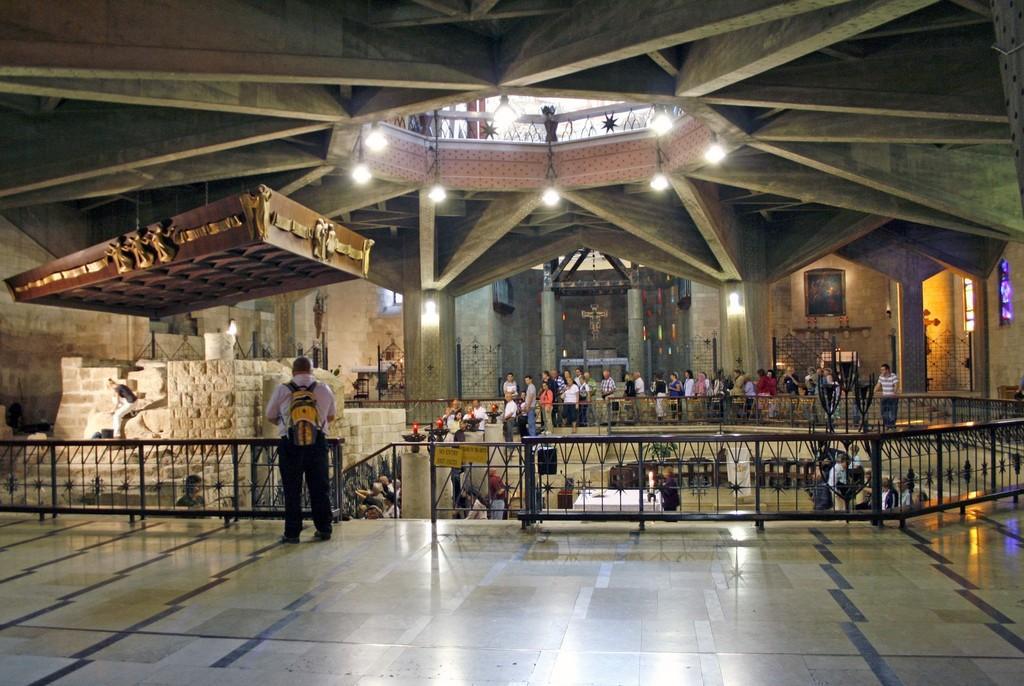Please provide a concise description of this image. This picture shows the inner view of a building. Some lights attached to the ceiling, some chairs, some people are sitting, some tables, some glass windows, some lights attached to the wall, two photo frames attached to the wall, some objects are on the floor, some people are sitting, two boards attached to the fence, one iron fence, some gates and some objects attached to the wall. 